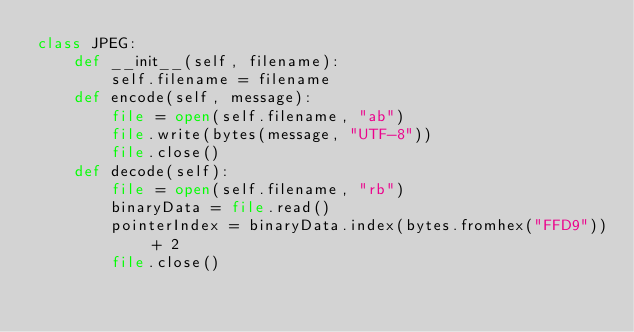<code> <loc_0><loc_0><loc_500><loc_500><_Python_>class JPEG:
	def __init__(self, filename):
		self.filename = filename
	def encode(self, message):
		file = open(self.filename, "ab")
		file.write(bytes(message, "UTF-8"))
		file.close()
	def decode(self):
		file = open(self.filename, "rb")
		binaryData = file.read()
		pointerIndex = binaryData.index(bytes.fromhex("FFD9")) + 2
		file.close()</code> 